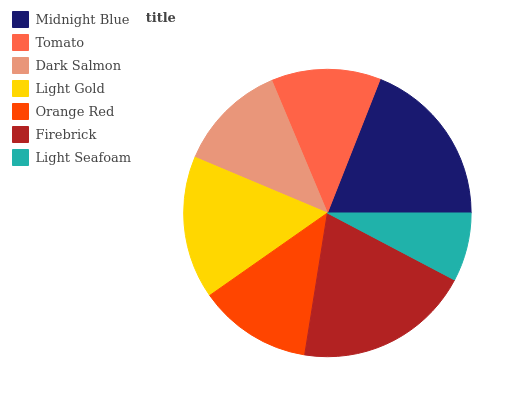Is Light Seafoam the minimum?
Answer yes or no. Yes. Is Firebrick the maximum?
Answer yes or no. Yes. Is Tomato the minimum?
Answer yes or no. No. Is Tomato the maximum?
Answer yes or no. No. Is Midnight Blue greater than Tomato?
Answer yes or no. Yes. Is Tomato less than Midnight Blue?
Answer yes or no. Yes. Is Tomato greater than Midnight Blue?
Answer yes or no. No. Is Midnight Blue less than Tomato?
Answer yes or no. No. Is Orange Red the high median?
Answer yes or no. Yes. Is Orange Red the low median?
Answer yes or no. Yes. Is Firebrick the high median?
Answer yes or no. No. Is Tomato the low median?
Answer yes or no. No. 